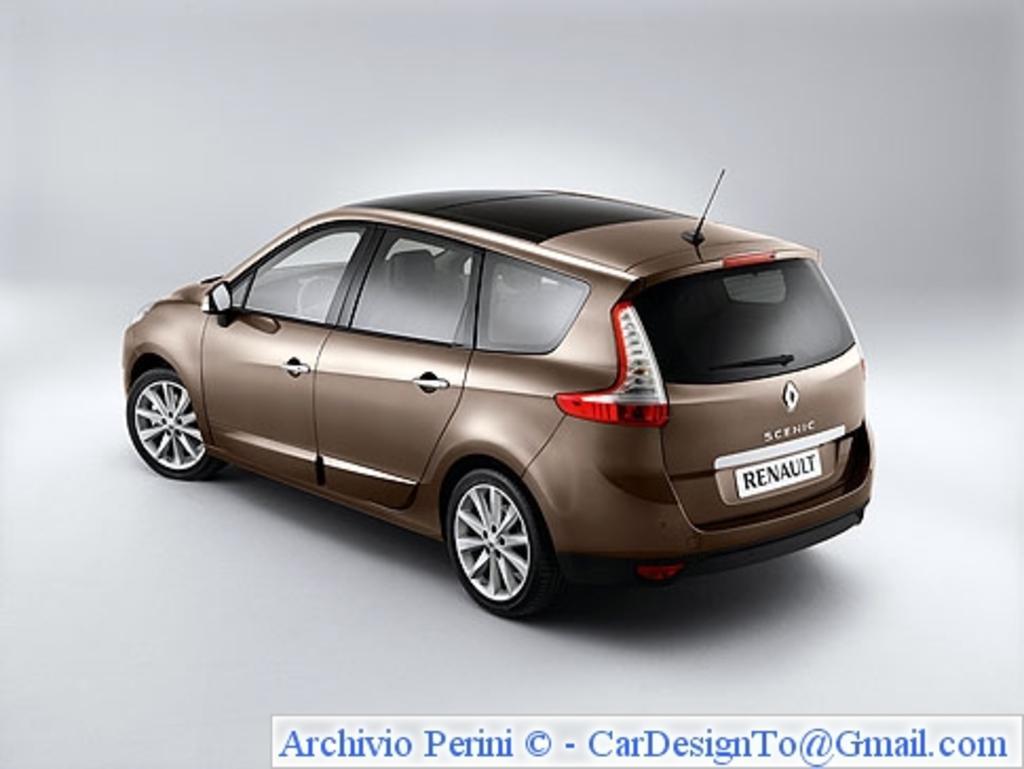Can you describe this image briefly? In this image in the center there is one car and there is white background, at the bottom of the image there is text. 